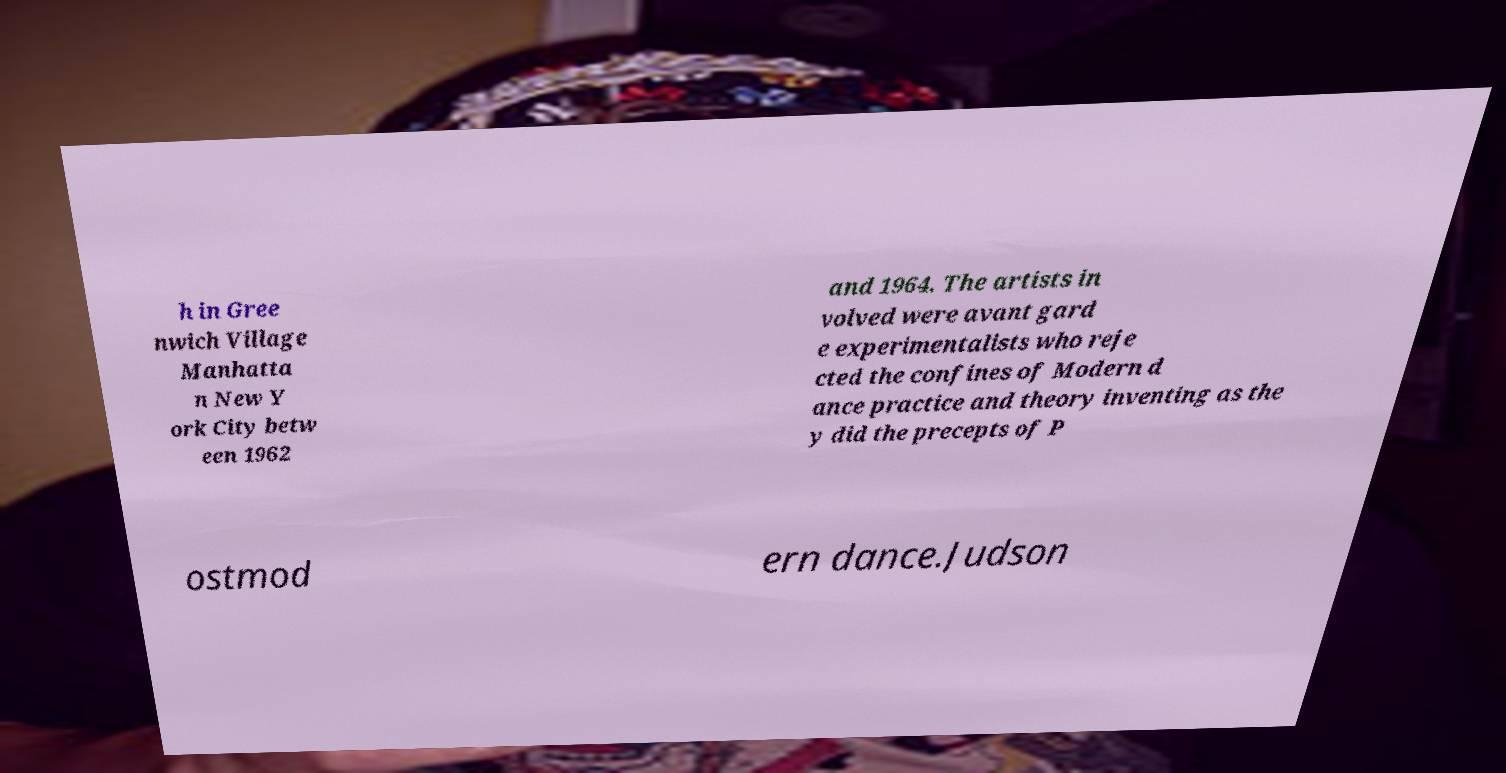For documentation purposes, I need the text within this image transcribed. Could you provide that? h in Gree nwich Village Manhatta n New Y ork City betw een 1962 and 1964. The artists in volved were avant gard e experimentalists who reje cted the confines of Modern d ance practice and theory inventing as the y did the precepts of P ostmod ern dance.Judson 